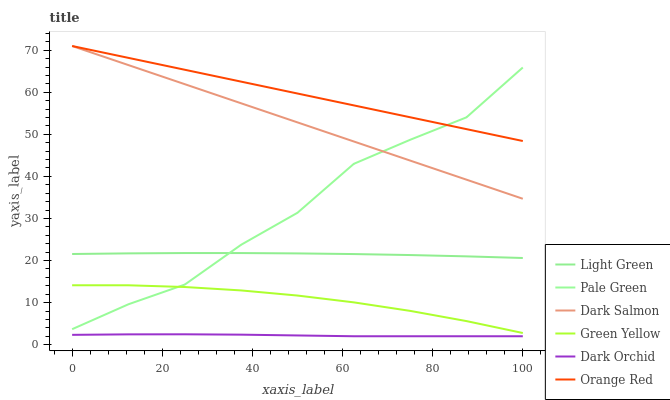Does Dark Orchid have the minimum area under the curve?
Answer yes or no. Yes. Does Orange Red have the maximum area under the curve?
Answer yes or no. Yes. Does Pale Green have the minimum area under the curve?
Answer yes or no. No. Does Pale Green have the maximum area under the curve?
Answer yes or no. No. Is Orange Red the smoothest?
Answer yes or no. Yes. Is Pale Green the roughest?
Answer yes or no. Yes. Is Dark Orchid the smoothest?
Answer yes or no. No. Is Dark Orchid the roughest?
Answer yes or no. No. Does Dark Orchid have the lowest value?
Answer yes or no. Yes. Does Pale Green have the lowest value?
Answer yes or no. No. Does Orange Red have the highest value?
Answer yes or no. Yes. Does Pale Green have the highest value?
Answer yes or no. No. Is Green Yellow less than Dark Salmon?
Answer yes or no. Yes. Is Light Green greater than Dark Orchid?
Answer yes or no. Yes. Does Orange Red intersect Pale Green?
Answer yes or no. Yes. Is Orange Red less than Pale Green?
Answer yes or no. No. Is Orange Red greater than Pale Green?
Answer yes or no. No. Does Green Yellow intersect Dark Salmon?
Answer yes or no. No. 